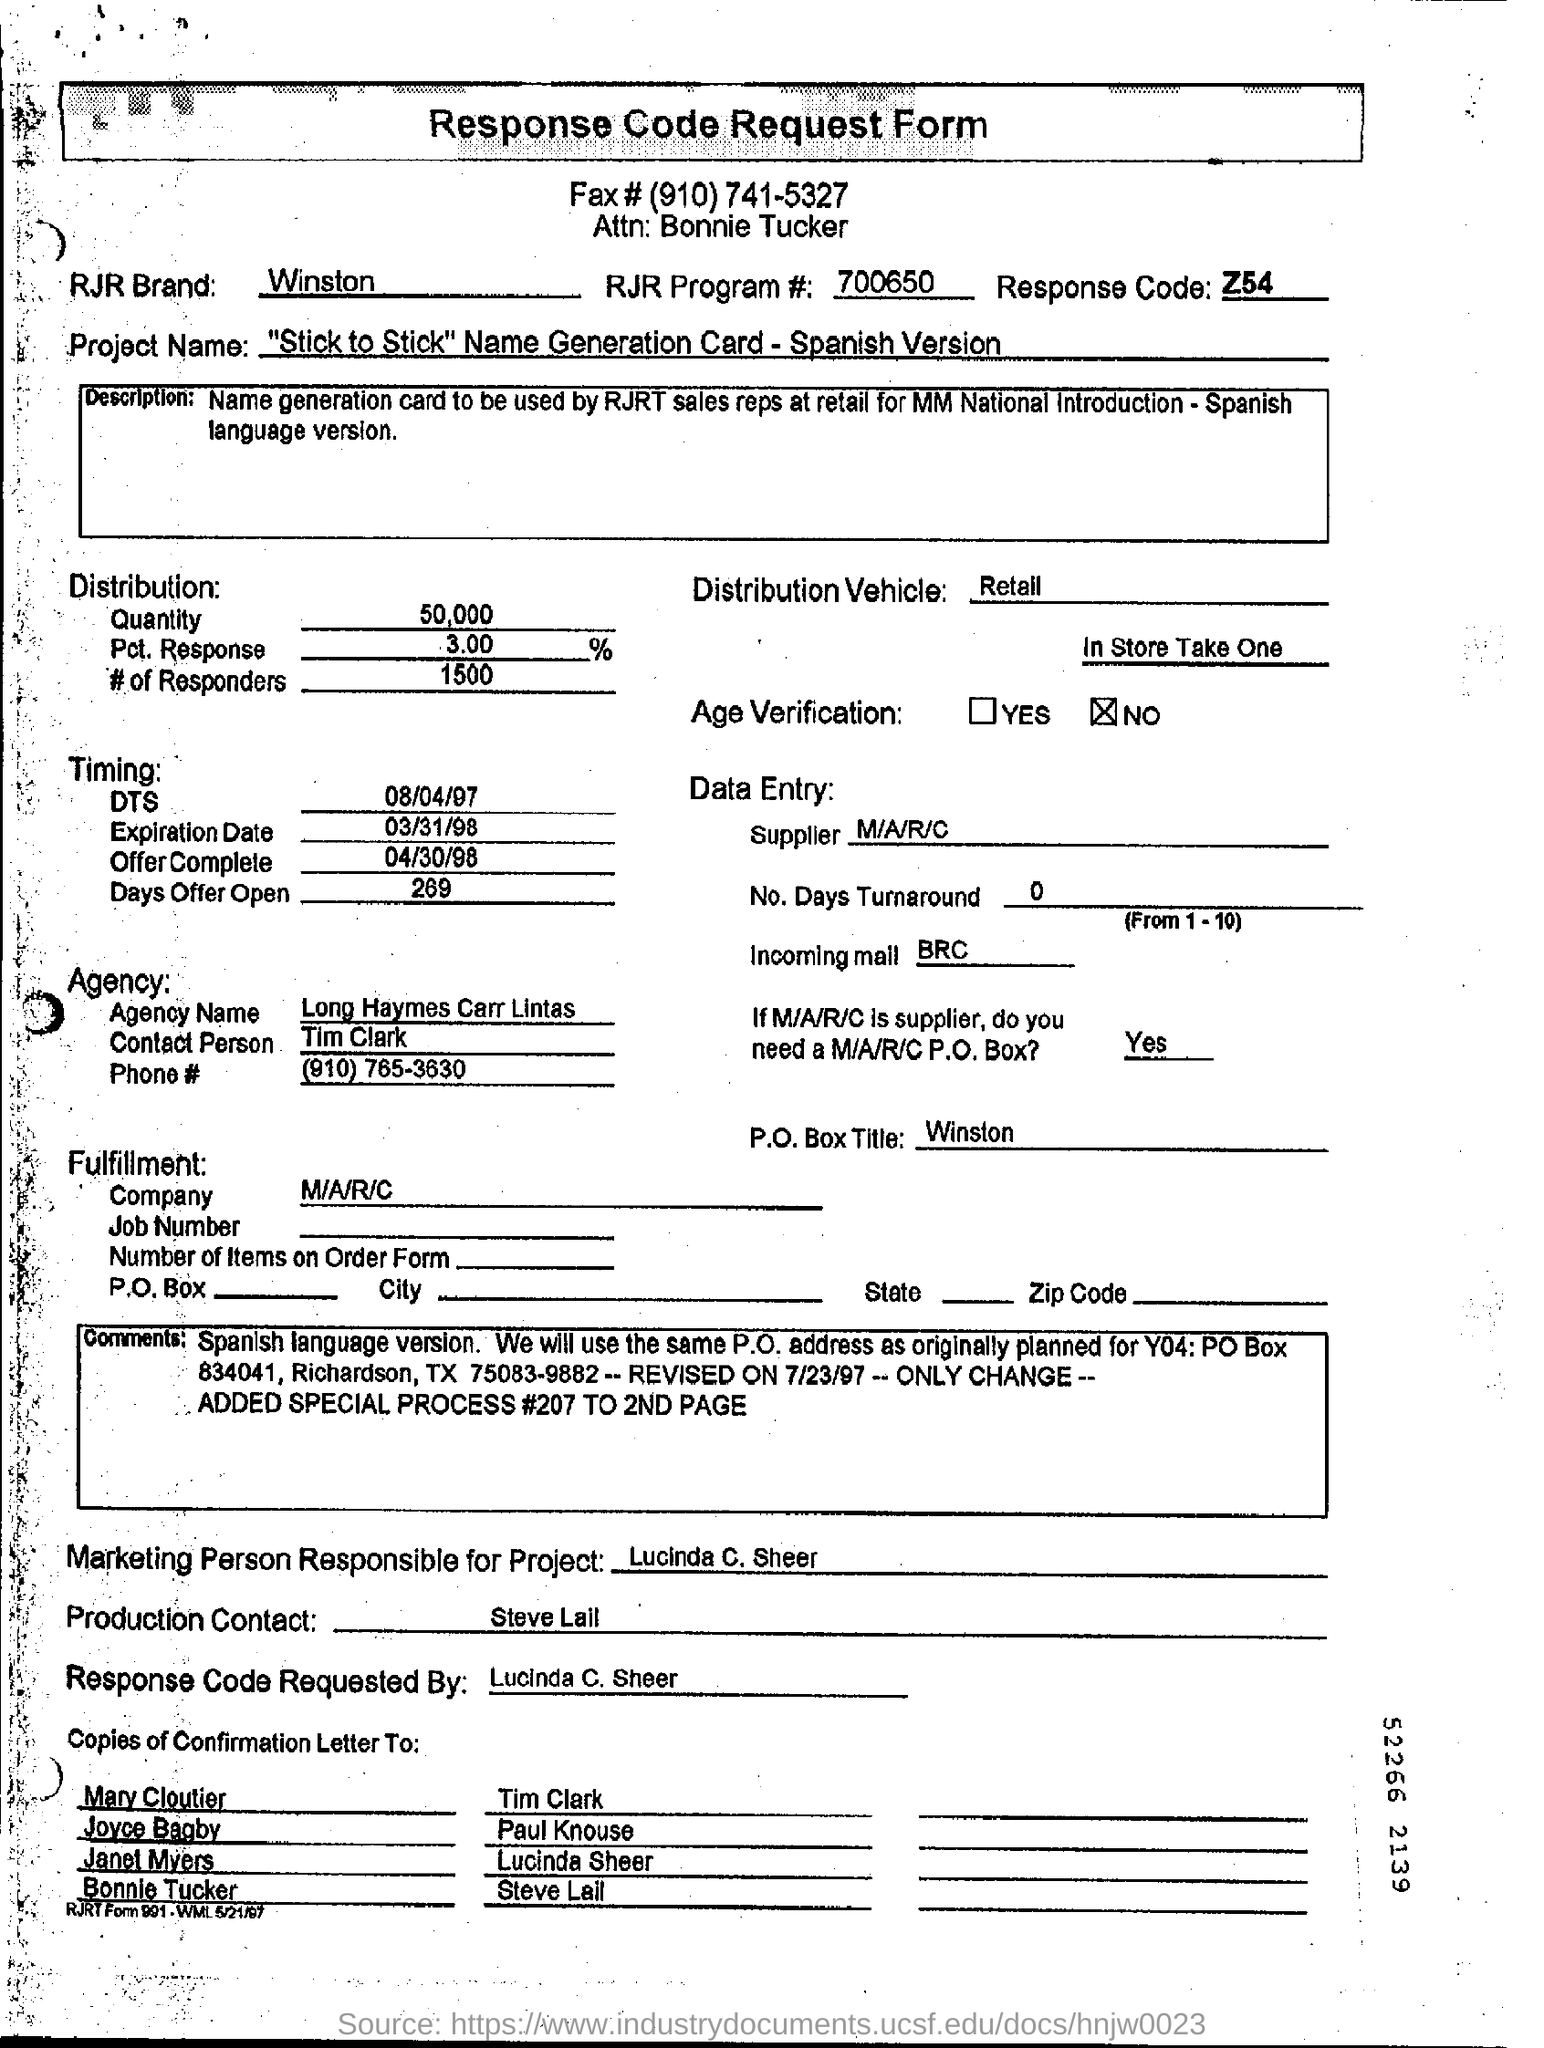Draw attention to some important aspects in this diagram. A response code was requested by Lucinda C. Sheer. The response code is Z54.. The RJR brand is known as Winston. There is no age verification required. The supplier is M/A/R/C. 